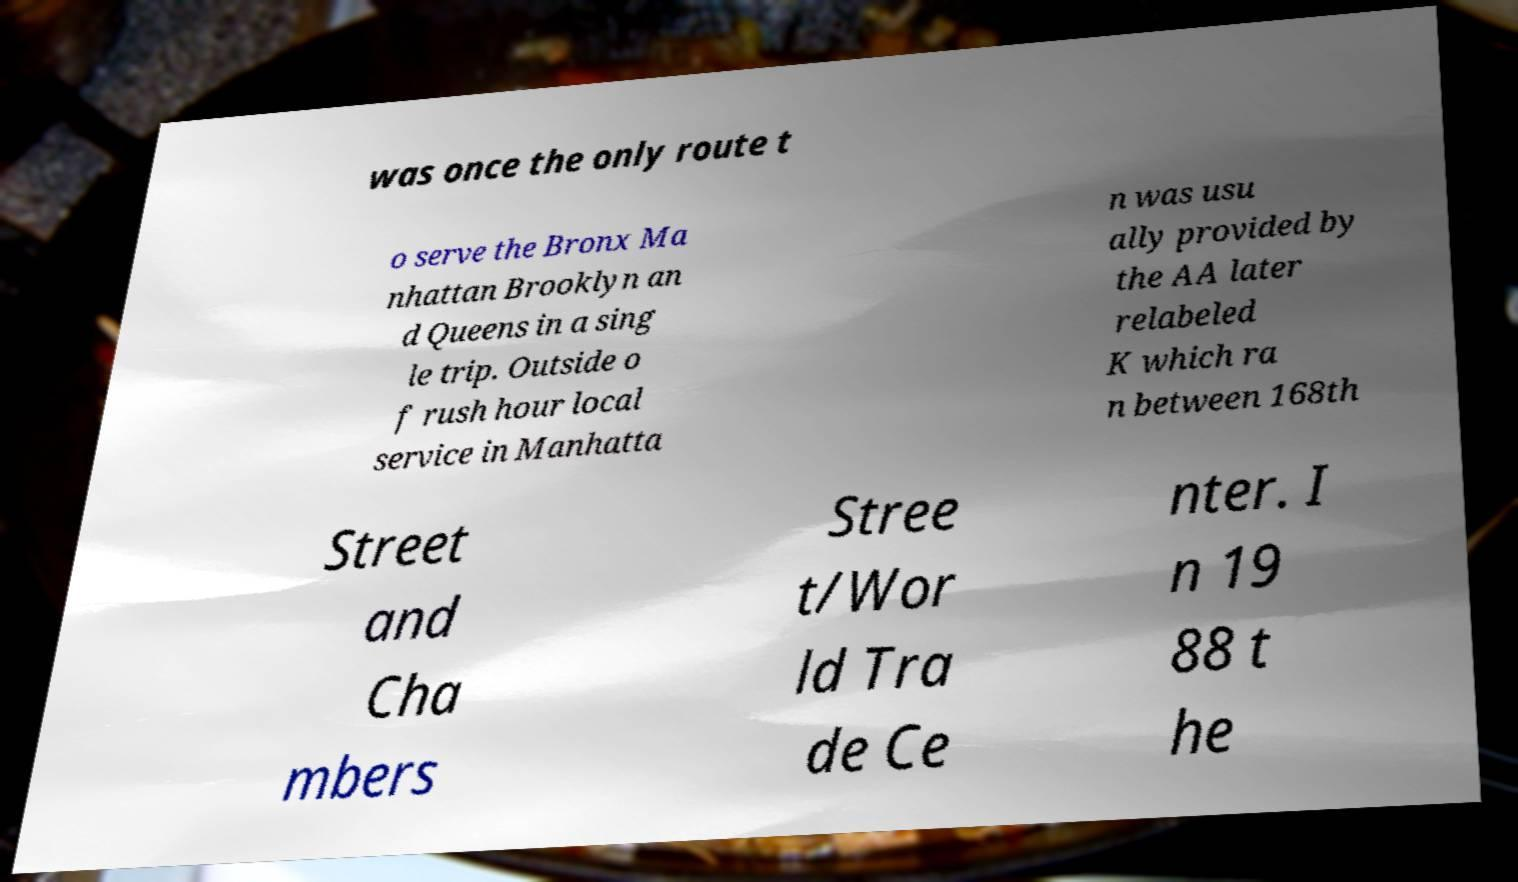I need the written content from this picture converted into text. Can you do that? was once the only route t o serve the Bronx Ma nhattan Brooklyn an d Queens in a sing le trip. Outside o f rush hour local service in Manhatta n was usu ally provided by the AA later relabeled K which ra n between 168th Street and Cha mbers Stree t/Wor ld Tra de Ce nter. I n 19 88 t he 